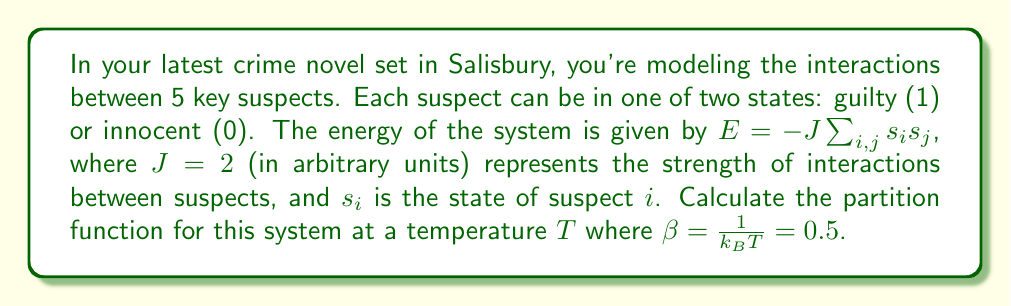Give your solution to this math problem. To calculate the partition function, we need to follow these steps:

1) The partition function is given by:
   $$Z = \sum_{\text{all states}} e^{-\beta E}$$

2) In this case, we have 5 suspects, each with 2 possible states. So there are $2^5 = 32$ total states.

3) For each state, we need to calculate the energy and then $e^{-\beta E}$.

4) The energy is given by $E = -J\sum_{i,j} s_i s_j$. For 5 suspects, there are 10 unique pairs of interactions.

5) Let's consider a few examples:
   - For the state (00000), E = 0
   - For the state (10000), E = 0
   - For the state (11000), E = -2J = -4
   - For the state (11111), E = -10J = -20

6) We need to calculate $e^{-\beta E}$ for each state. For example:
   - For (00000): $e^{-0.5 * 0} = 1$
   - For (11000): $e^{-0.5 * (-4)} = e^2 \approx 7.389$
   - For (11111): $e^{-0.5 * (-20)} = e^{10} \approx 22026.465$

7) We need to sum these values for all 32 states. Due to symmetry, we can group states with the same energy:
   - 1 state with E = -20J
   - 5 states with E = -12J
   - 10 states with E = -6J
   - 10 states with E = -2J
   - 5 states with E = 0
   - 1 state with E = 0

8) Summing these up:
   $$Z = e^{10} + 5e^6 + 10e^3 + 10e^1 + 6$$

9) Calculating this sum gives us the final partition function.
Answer: $Z \approx 22371.37$ 